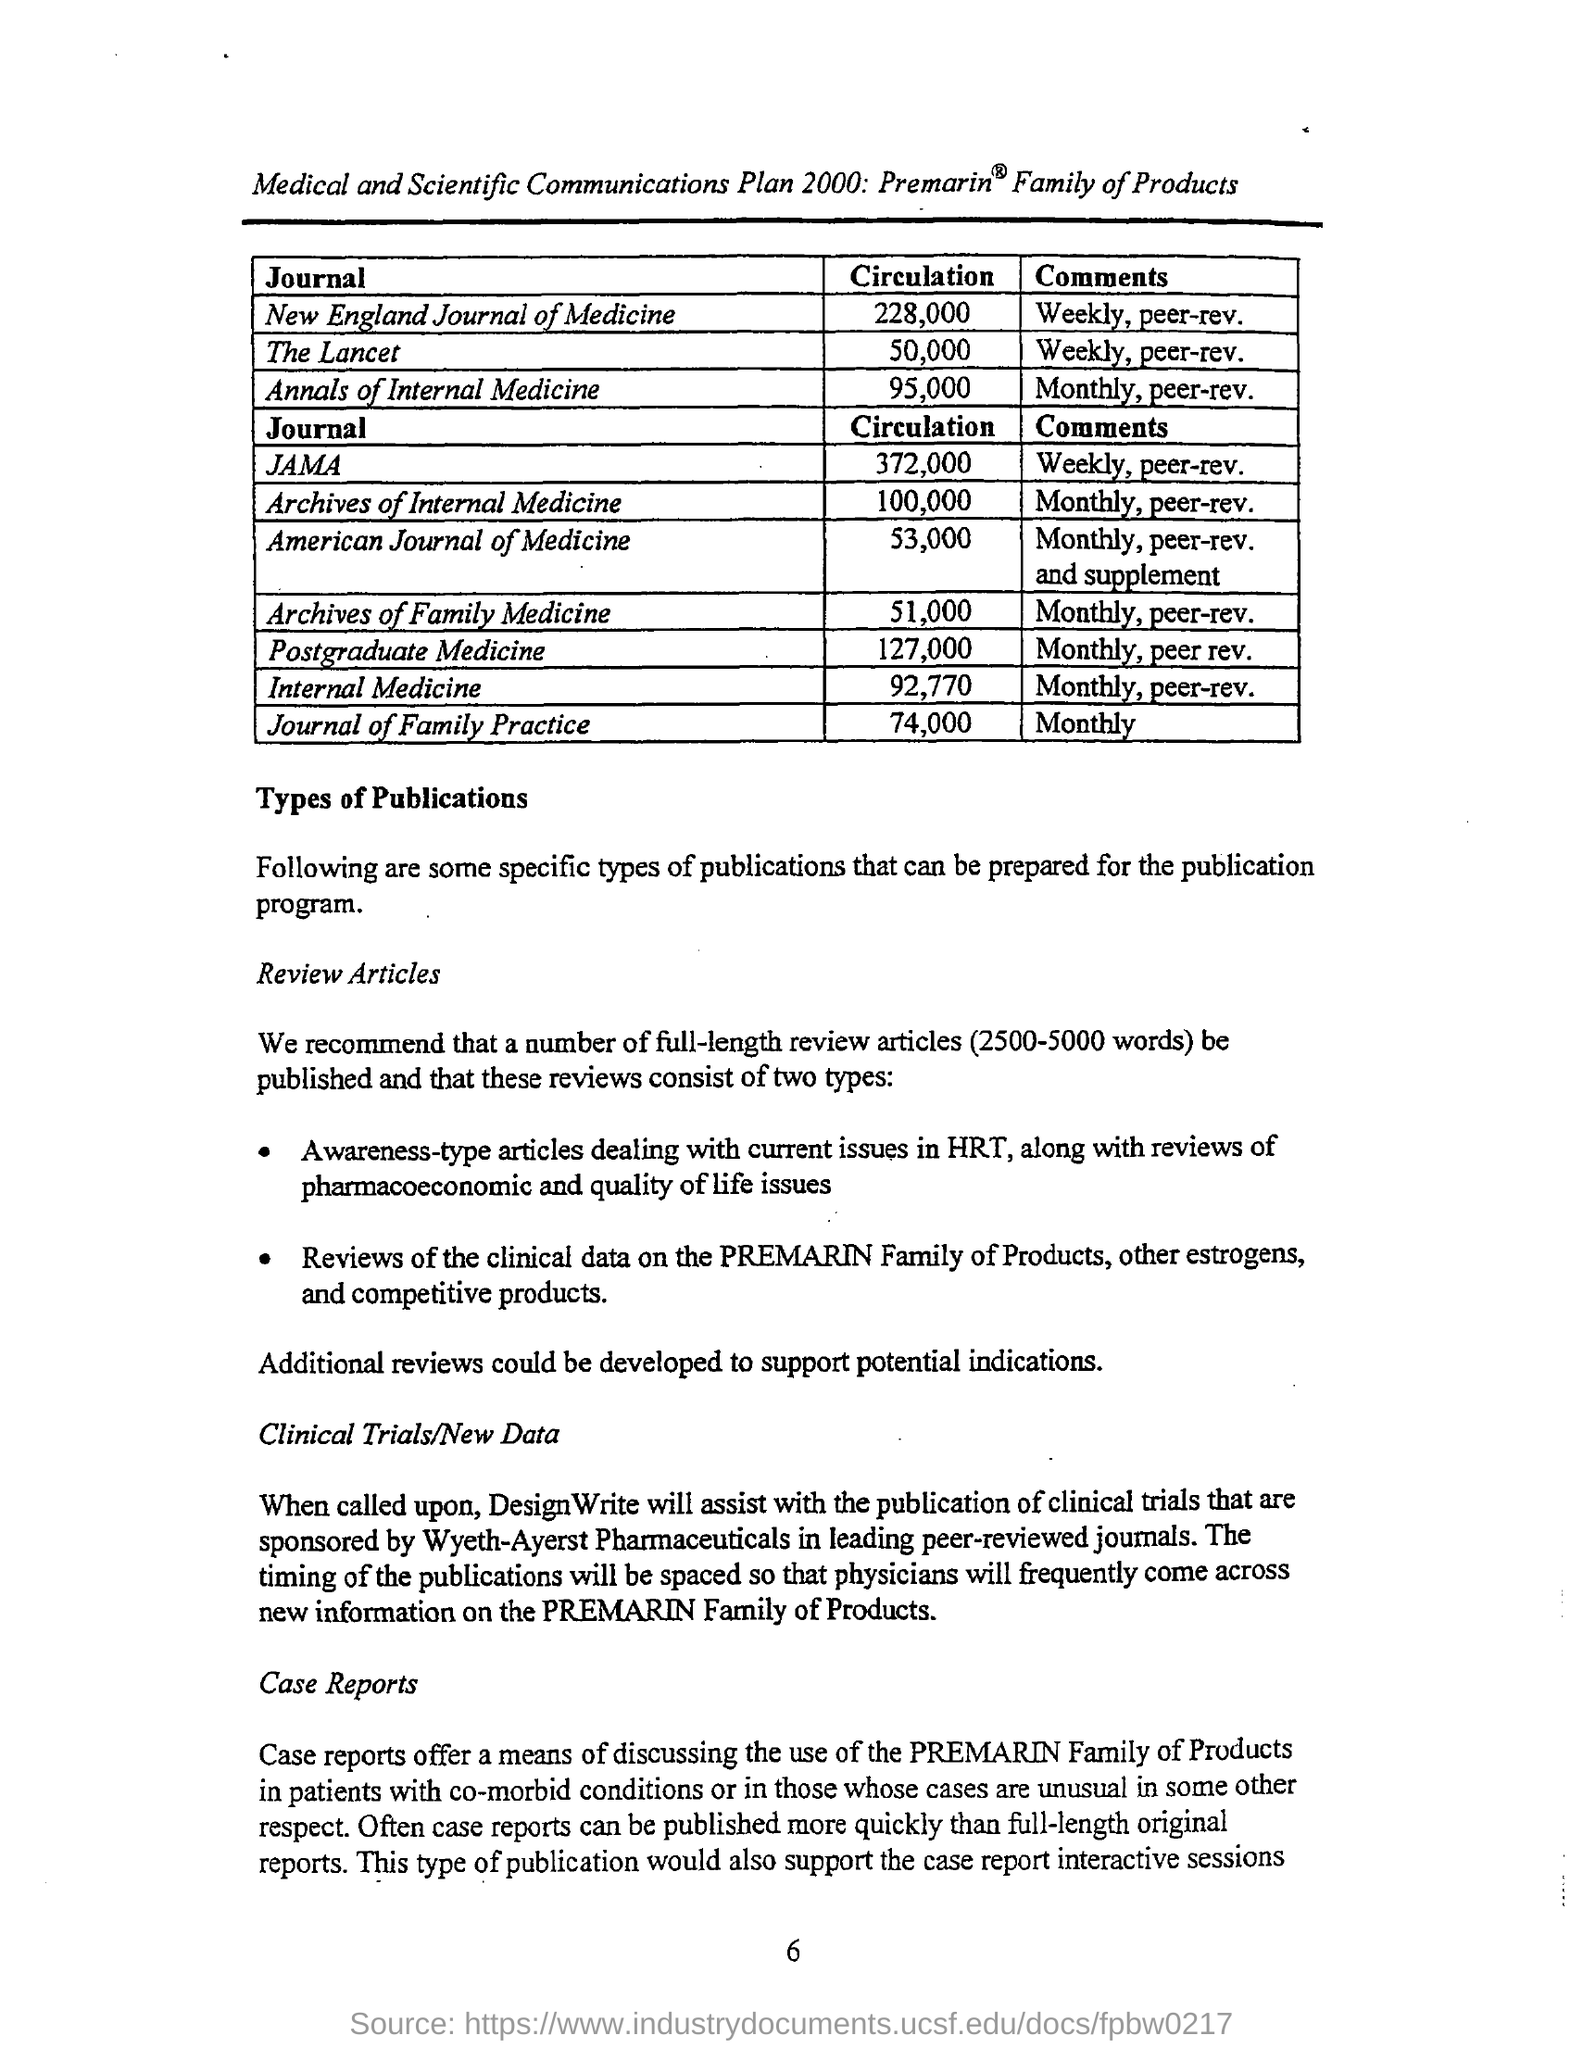Mention a couple of crucial points in this snapshot. The journal of family practice has comments that are mentioned for being published monthly. The circulation for internal medicine mentioned in the given page is 92,770. The circulation value for archives of internal medicine is approximately 100,000. The circulation value for postgraduate medicine mentioned in the given page is 127,000. The Lancet Journal products have comments that are weekly and peer-reviewed. 